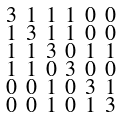Convert formula to latex. <formula><loc_0><loc_0><loc_500><loc_500>\begin{smallmatrix} 3 & 1 & 1 & 1 & 0 & 0 \\ 1 & 3 & 1 & 1 & 0 & 0 \\ 1 & 1 & 3 & 0 & 1 & 1 \\ 1 & 1 & 0 & 3 & 0 & 0 \\ 0 & 0 & 1 & 0 & 3 & 1 \\ 0 & 0 & 1 & 0 & 1 & 3 \end{smallmatrix}</formula> 